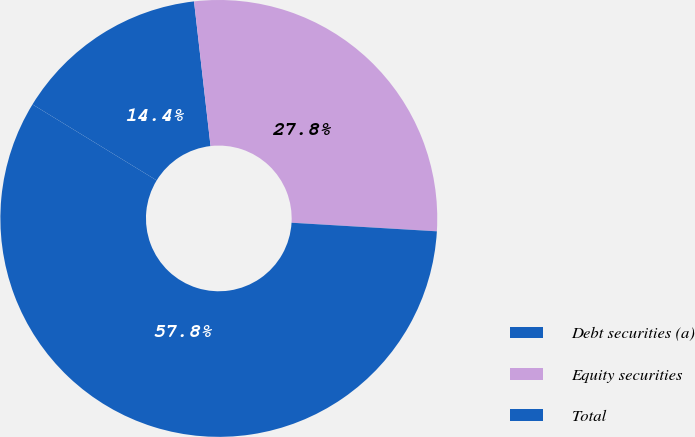Convert chart. <chart><loc_0><loc_0><loc_500><loc_500><pie_chart><fcel>Debt securities (a)<fcel>Equity securities<fcel>Total<nl><fcel>14.45%<fcel>27.75%<fcel>57.8%<nl></chart> 